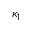Convert formula to latex. <formula><loc_0><loc_0><loc_500><loc_500>\kappa _ { 1 }</formula> 